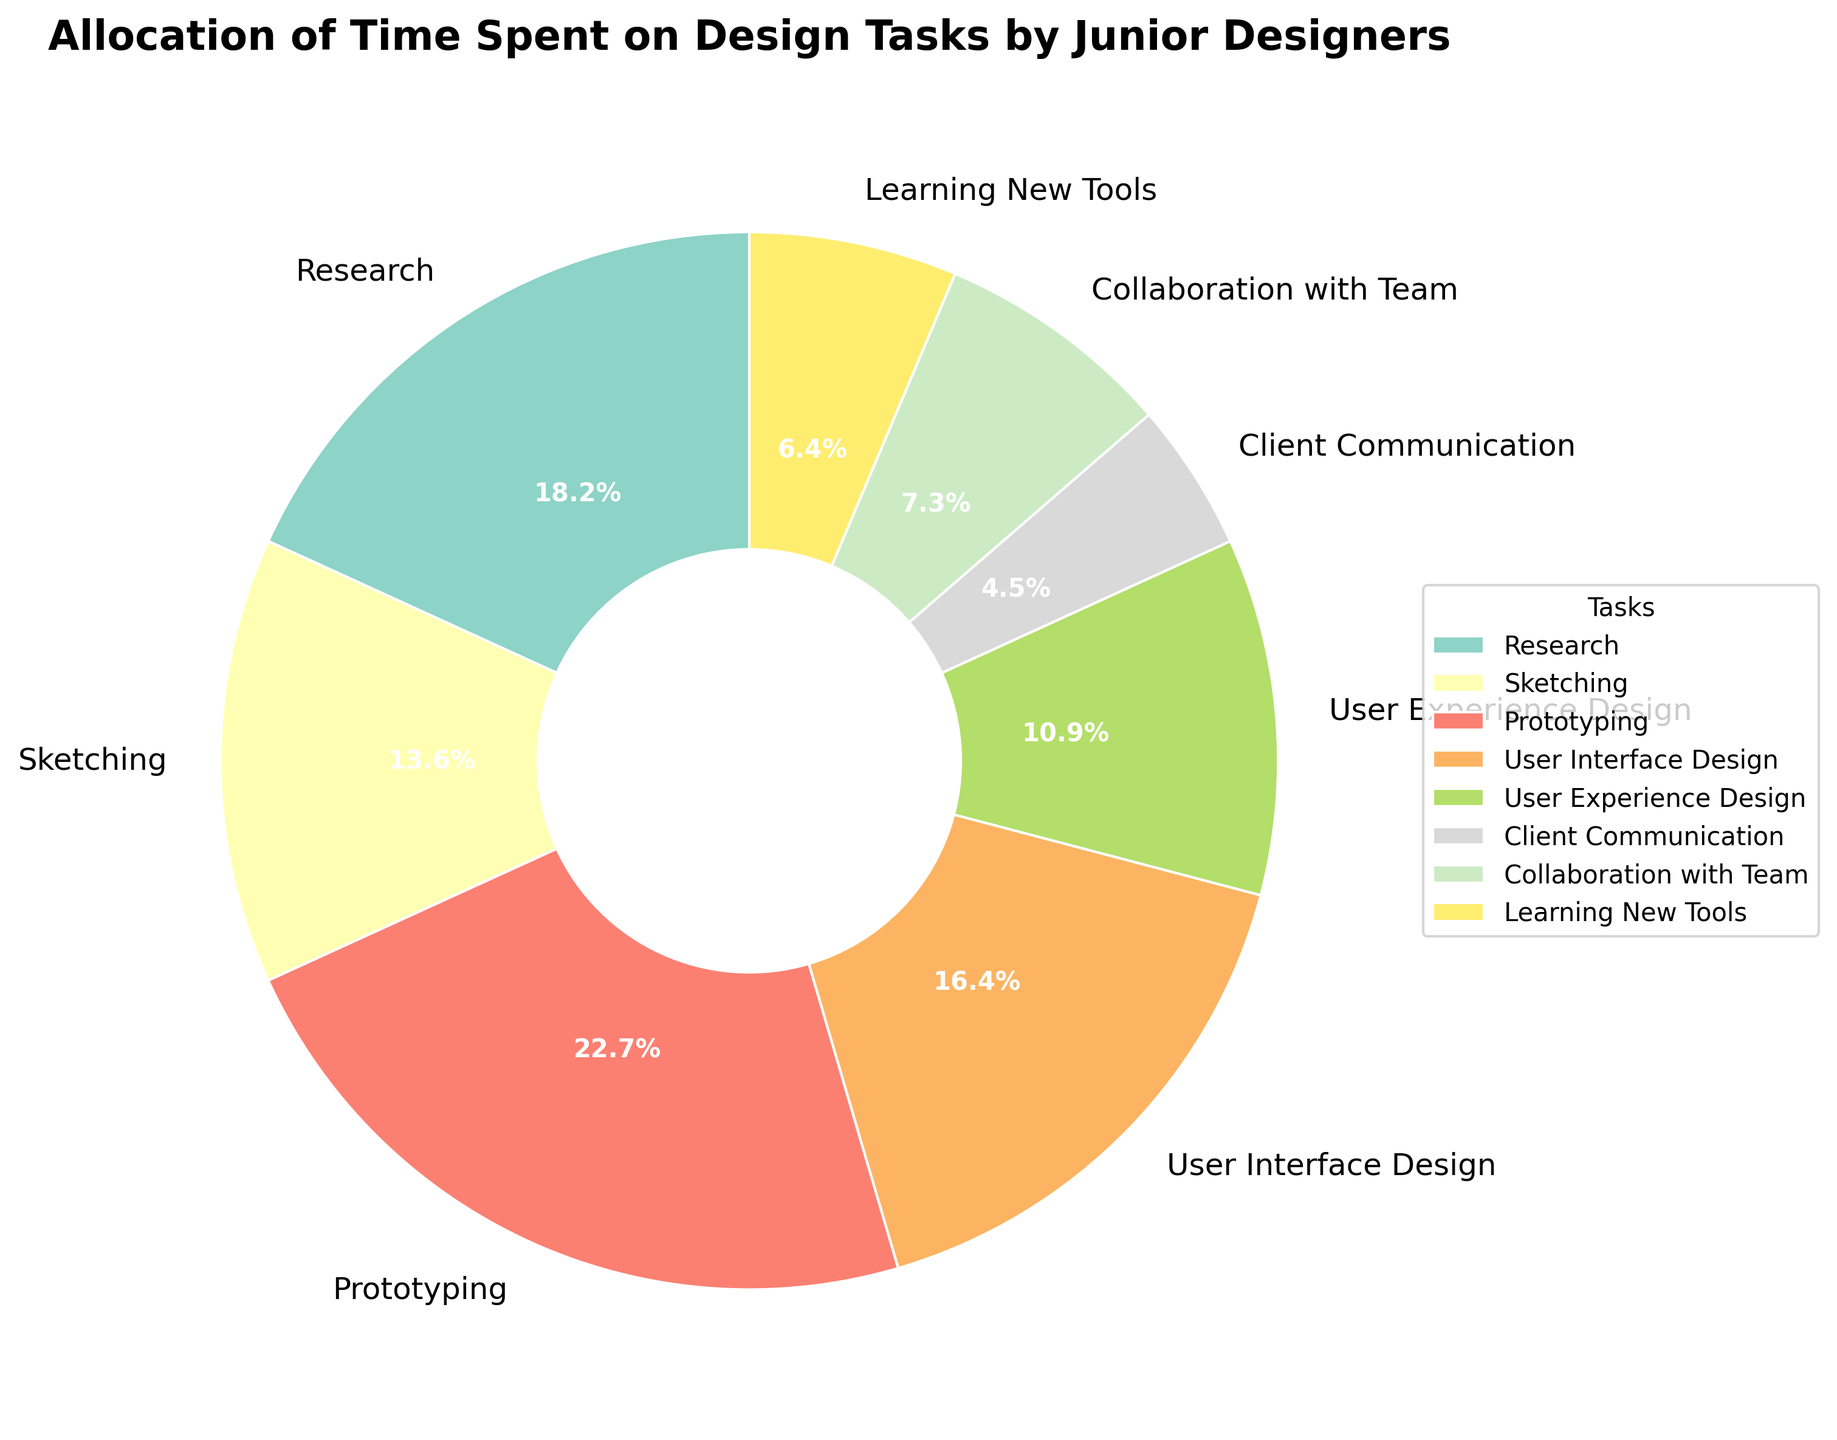what percentage of time do junior designers spend on prototyping? To answer this, look at the section of the pie chart labeled "Prototyping" and read the accompanying percentage label.
Answer: 25% what tasks are allocated the least and most amount of time respectively? The smallest slice represents the least time spent, and the largest slice represents the most time spent. "Client Communication" is the smallest at 5%, and "Prototyping" is the largest at 25%.
Answer: Client Communication and Prototyping is more time spent on research or sketching? Compare the slices labeled "Research" and "Sketching". Research has 20%, and Sketching has 15%.
Answer: Research what is the total percentage of time spent on client communication and collaboration with the team? Sum the percentages for "Client Communication" (5%) and "Collaboration with Team" (8%). 5% + 8% = 13%
Answer: 13% which task category occupies the second largest portion of the pie chart? The slice size indicates the portion; "Research" is the second largest at 20%.
Answer: Research how much more time is spent on user interface design compared to learning new tools? Subtract the percentage for "Learning New Tools" (7%) from "User Interface Design" (18%). 18% - 7% = 11%
Answer: 11% do junior designers spend more time on user experience design or on sketching? Compare the percentages of "User Experience Design" (12%) and "Sketching" (15%).
Answer: Sketching what is the combined percentage of time spent on user interface design and user experience design? Add the percentages for "User Interface Design" (18%) and "User Experience Design" (12%). 18% + 12% = 30%
Answer: 30% what is the average percentage of time spent on client communication, collaboration with team, and learning new tools? Sum the percentages for these tasks and then divide by the number of tasks: (5% + 8% + 7%) / 3 = 20% / 3 ≈ 6.67%
Answer: ~6.67% if junior designers wanted to spend no more than 50% of their time on research, sketching, and prototyping combined, would they succeed based on the chart? Sum the percentages for "Research" (20%), "Sketching" (15%), and "Prototyping" (25%). 20% + 15% + 25% = 60%, which is more than 50%.
Answer: No 